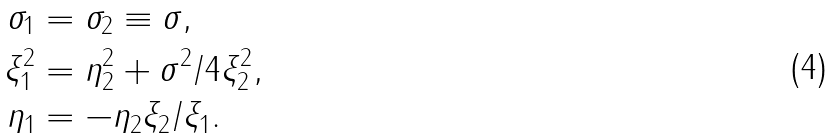<formula> <loc_0><loc_0><loc_500><loc_500>\sigma _ { 1 } & = \sigma _ { 2 } \equiv \sigma , \\ \xi _ { 1 } ^ { 2 } & = \eta _ { 2 } ^ { 2 } + { \sigma ^ { 2 } } / { 4 \xi _ { 2 } ^ { 2 } } , \\ \eta _ { 1 } & = - \eta _ { 2 } { \xi _ { 2 } } / { \xi _ { 1 } } .</formula> 